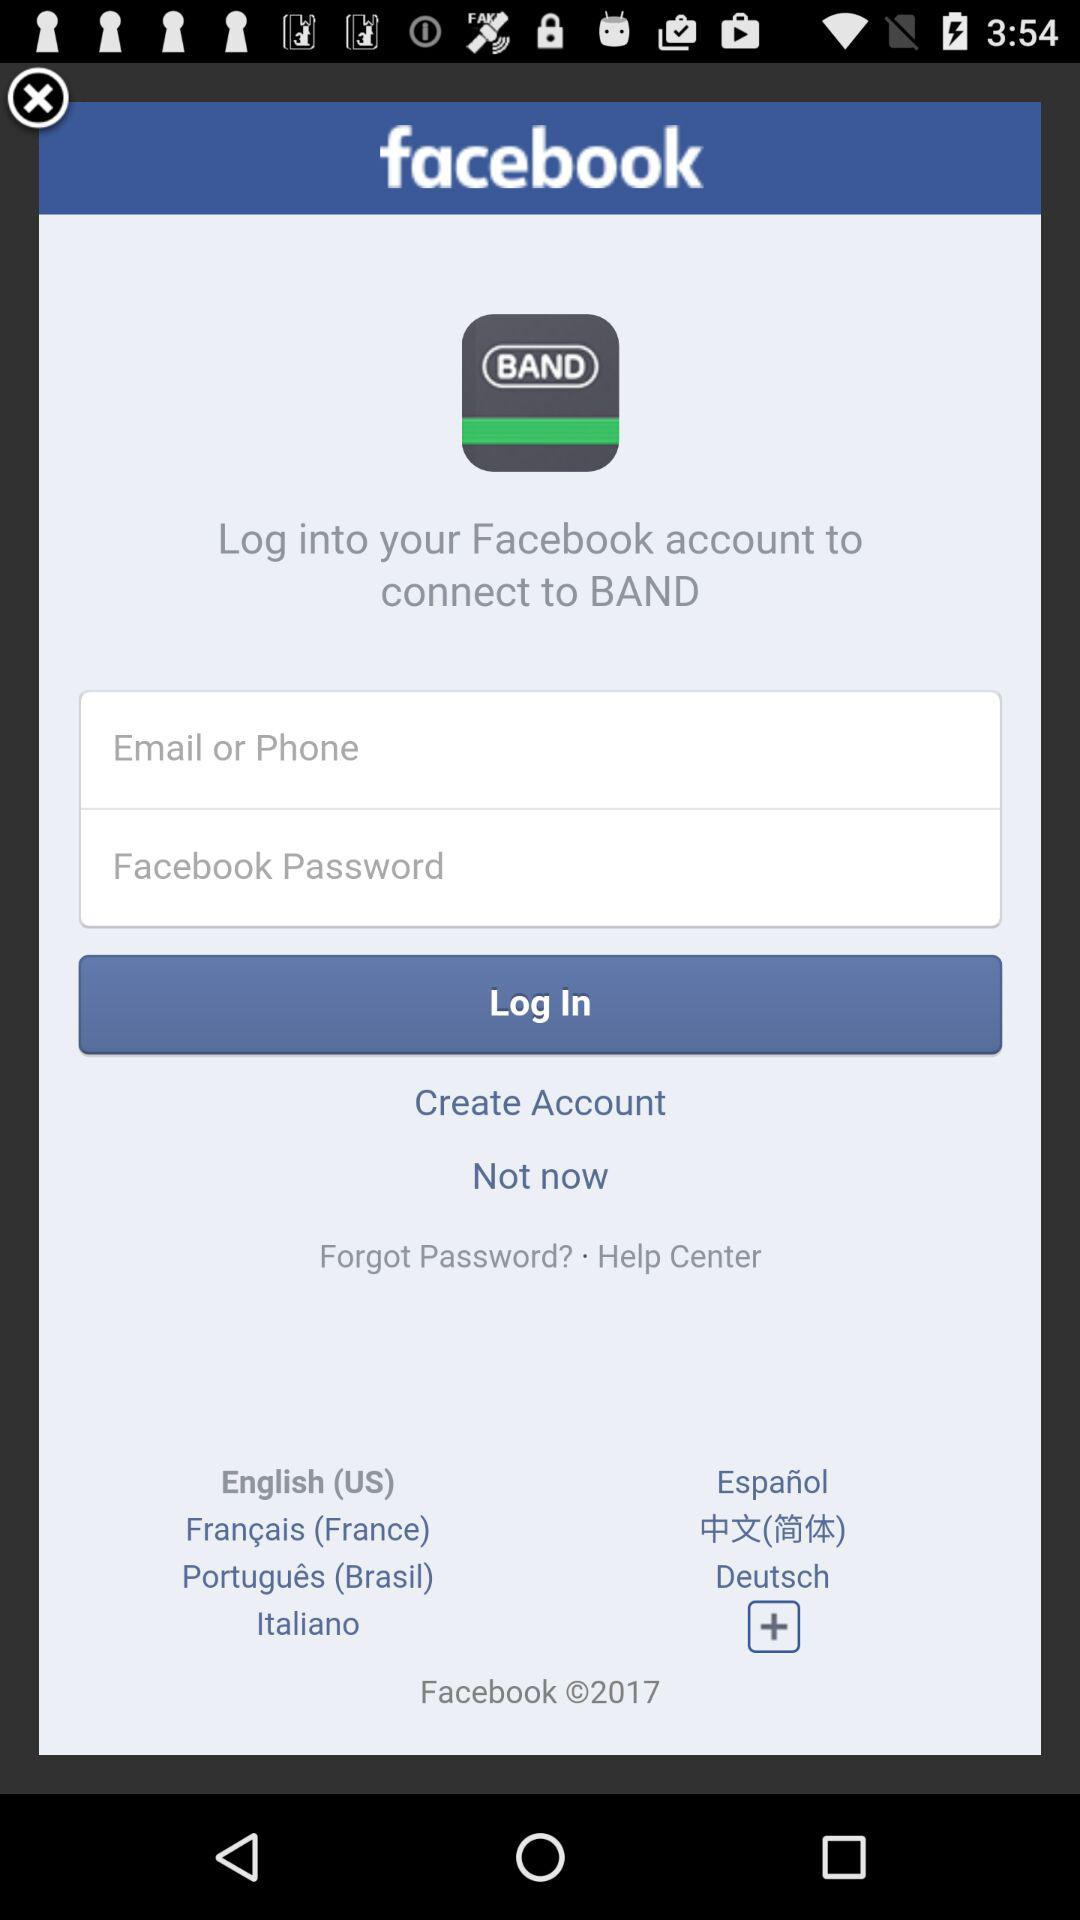What is the application name? The application names are "BAND" and "facebook". 